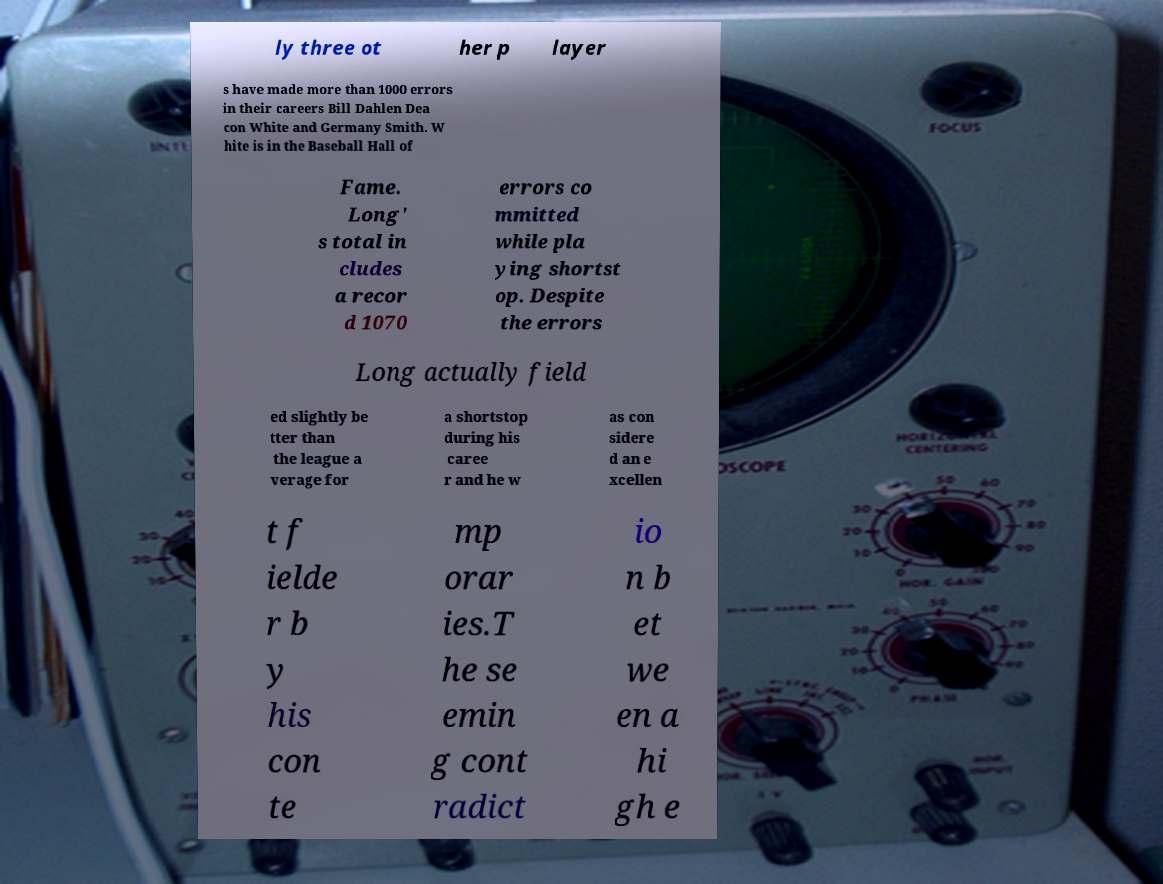Please read and relay the text visible in this image. What does it say? ly three ot her p layer s have made more than 1000 errors in their careers Bill Dahlen Dea con White and Germany Smith. W hite is in the Baseball Hall of Fame. Long' s total in cludes a recor d 1070 errors co mmitted while pla ying shortst op. Despite the errors Long actually field ed slightly be tter than the league a verage for a shortstop during his caree r and he w as con sidere d an e xcellen t f ielde r b y his con te mp orar ies.T he se emin g cont radict io n b et we en a hi gh e 